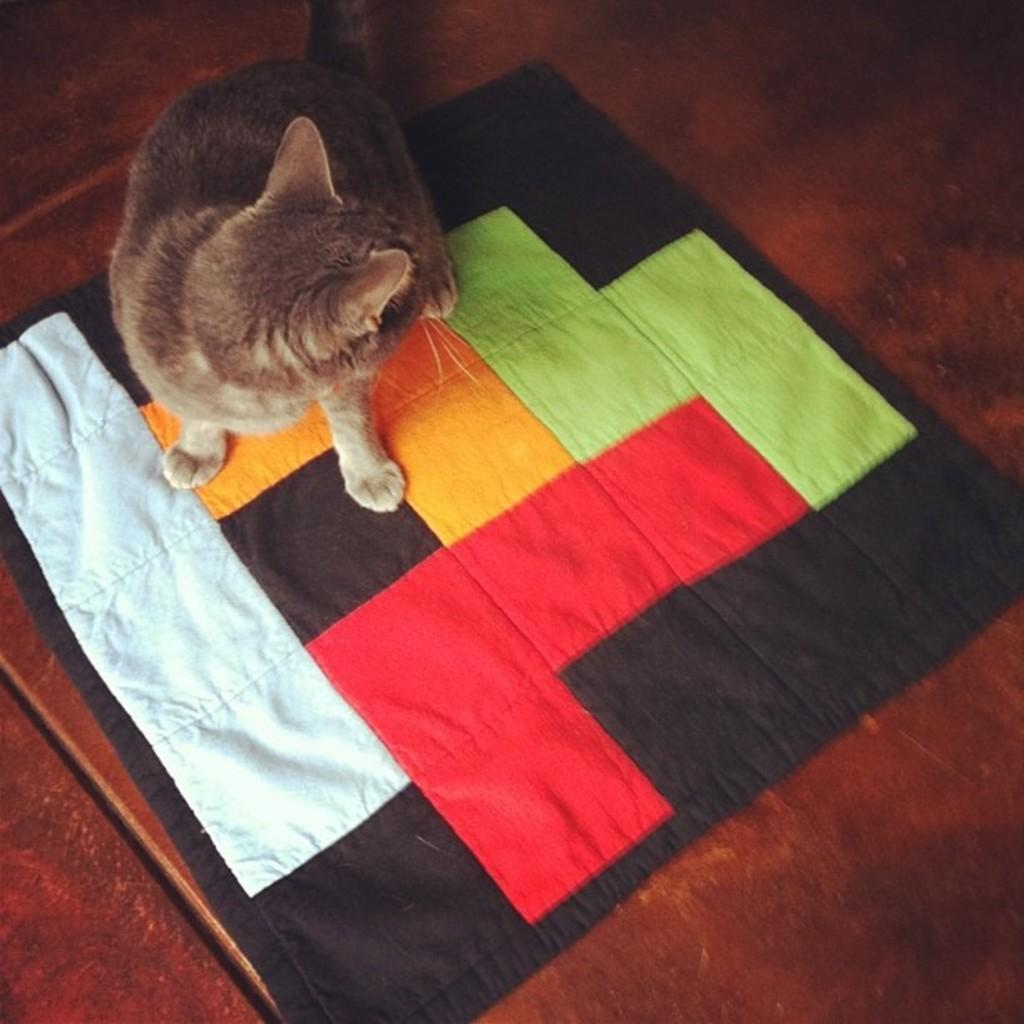What type of animal is in the image? There is a brown cat in the image. What surface is the cat on? The cat is on a carpet. Can you describe the carpet in the image? The carpet has multiple colors, including white, red, yellow, green, and black. What is the color of the table or floor at the bottom of the image? The table or floor at the bottom of the image is brown. How does the cat feel about the wrist operation in the image? There is no wrist operation or any mention of feelings in the image; it only features a brown cat on a carpet. 